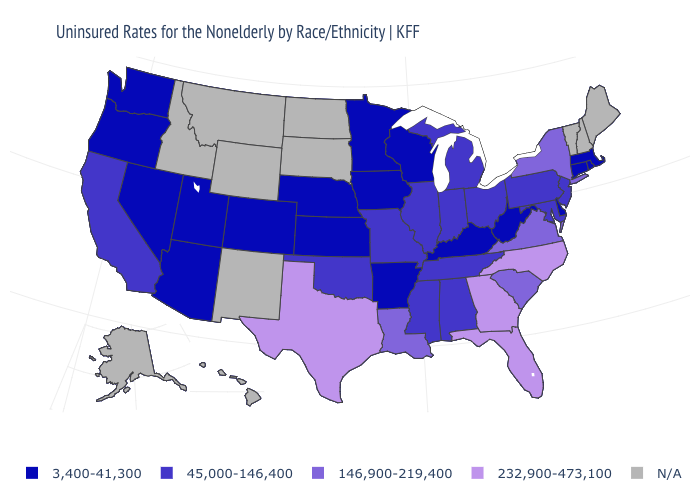Name the states that have a value in the range 45,000-146,400?
Answer briefly. Alabama, California, Illinois, Indiana, Maryland, Michigan, Mississippi, Missouri, New Jersey, Ohio, Oklahoma, Pennsylvania, Tennessee. How many symbols are there in the legend?
Give a very brief answer. 5. Does the map have missing data?
Concise answer only. Yes. Name the states that have a value in the range 146,900-219,400?
Give a very brief answer. Louisiana, New York, South Carolina, Virginia. What is the value of Louisiana?
Answer briefly. 146,900-219,400. What is the value of Alaska?
Keep it brief. N/A. What is the value of Alabama?
Be succinct. 45,000-146,400. Name the states that have a value in the range 45,000-146,400?
Be succinct. Alabama, California, Illinois, Indiana, Maryland, Michigan, Mississippi, Missouri, New Jersey, Ohio, Oklahoma, Pennsylvania, Tennessee. Which states have the lowest value in the Northeast?
Keep it brief. Connecticut, Massachusetts, Rhode Island. What is the value of Delaware?
Be succinct. 3,400-41,300. Which states have the lowest value in the Northeast?
Give a very brief answer. Connecticut, Massachusetts, Rhode Island. Does Louisiana have the lowest value in the USA?
Concise answer only. No. 